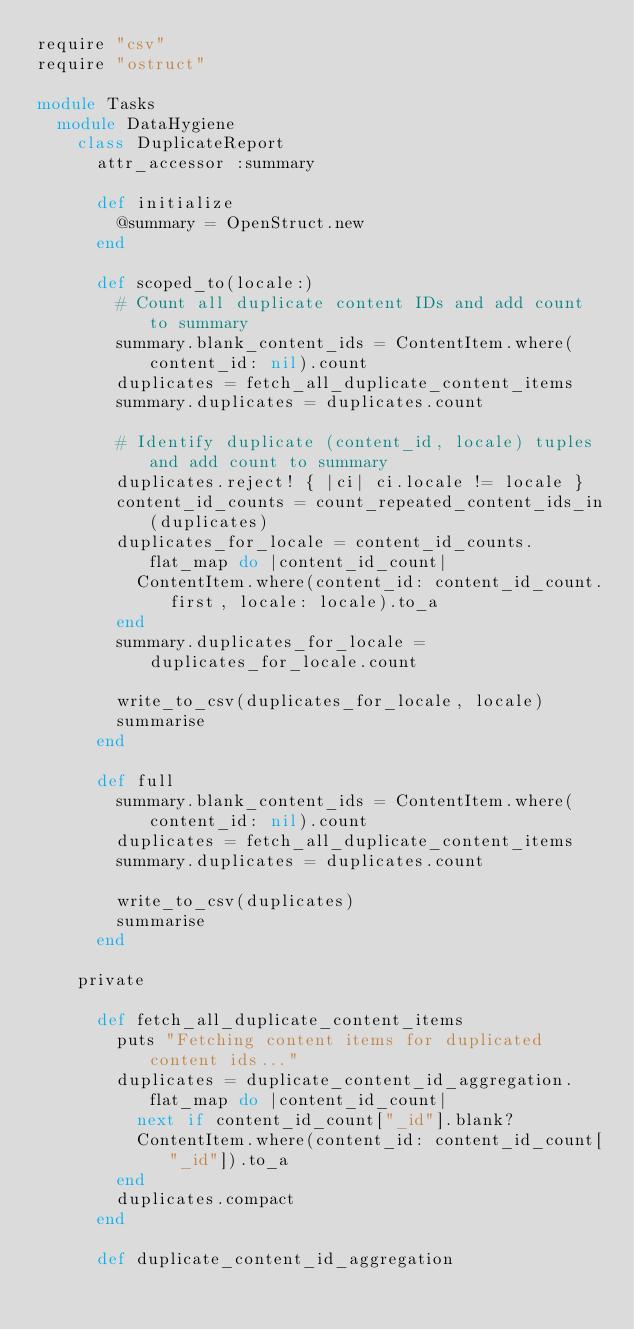Convert code to text. <code><loc_0><loc_0><loc_500><loc_500><_Ruby_>require "csv"
require "ostruct"

module Tasks
  module DataHygiene
    class DuplicateReport
      attr_accessor :summary

      def initialize
        @summary = OpenStruct.new
      end

      def scoped_to(locale:)
        # Count all duplicate content IDs and add count to summary
        summary.blank_content_ids = ContentItem.where(content_id: nil).count
        duplicates = fetch_all_duplicate_content_items
        summary.duplicates = duplicates.count

        # Identify duplicate (content_id, locale) tuples and add count to summary
        duplicates.reject! { |ci| ci.locale != locale }
        content_id_counts = count_repeated_content_ids_in(duplicates)
        duplicates_for_locale = content_id_counts.flat_map do |content_id_count|
          ContentItem.where(content_id: content_id_count.first, locale: locale).to_a
        end
        summary.duplicates_for_locale = duplicates_for_locale.count

        write_to_csv(duplicates_for_locale, locale)
        summarise
      end

      def full
        summary.blank_content_ids = ContentItem.where(content_id: nil).count
        duplicates = fetch_all_duplicate_content_items
        summary.duplicates = duplicates.count

        write_to_csv(duplicates)
        summarise
      end

    private

      def fetch_all_duplicate_content_items
        puts "Fetching content items for duplicated content ids..."
        duplicates = duplicate_content_id_aggregation.flat_map do |content_id_count|
          next if content_id_count["_id"].blank?
          ContentItem.where(content_id: content_id_count["_id"]).to_a
        end
        duplicates.compact
      end

      def duplicate_content_id_aggregation</code> 